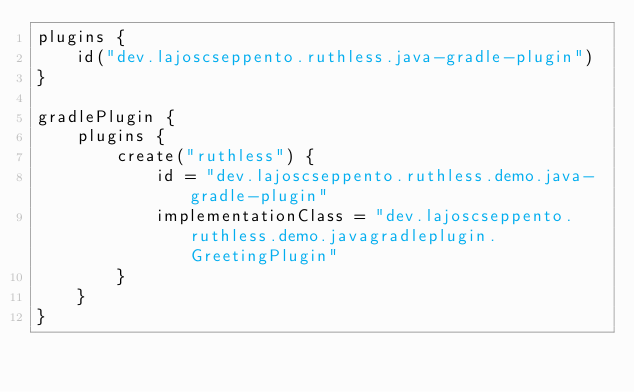<code> <loc_0><loc_0><loc_500><loc_500><_Kotlin_>plugins {
    id("dev.lajoscseppento.ruthless.java-gradle-plugin")
}

gradlePlugin {
    plugins {
        create("ruthless") {
            id = "dev.lajoscseppento.ruthless.demo.java-gradle-plugin"
            implementationClass = "dev.lajoscseppento.ruthless.demo.javagradleplugin.GreetingPlugin"
        }
    }
}
</code> 